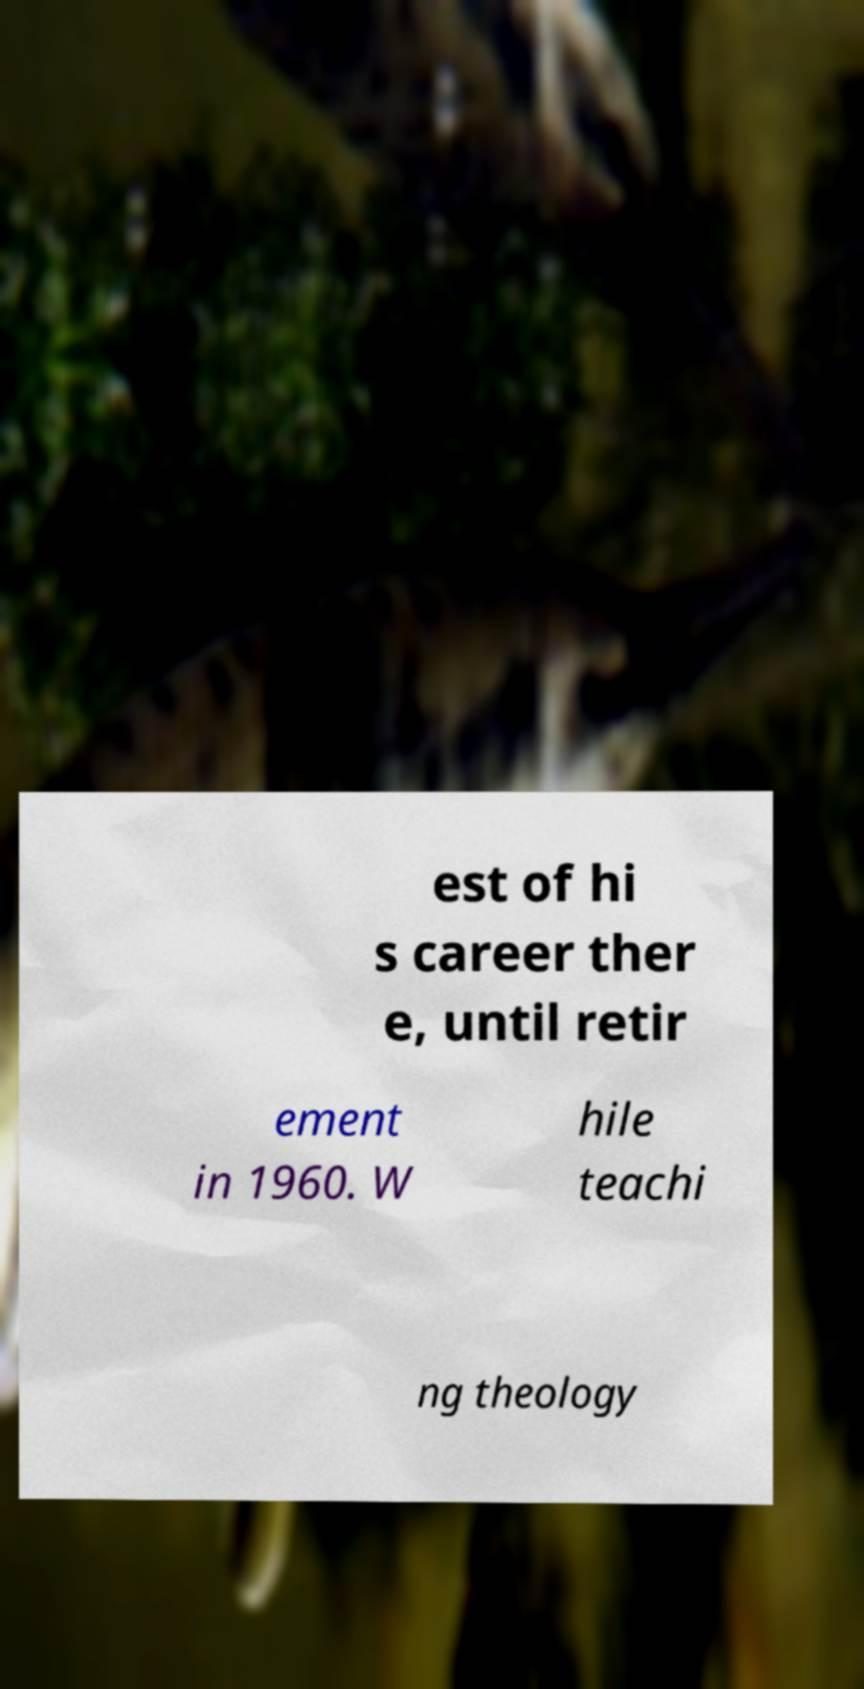Could you assist in decoding the text presented in this image and type it out clearly? est of hi s career ther e, until retir ement in 1960. W hile teachi ng theology 